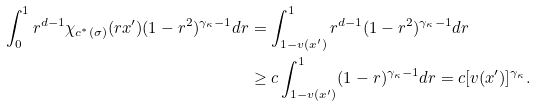Convert formula to latex. <formula><loc_0><loc_0><loc_500><loc_500>\int _ { 0 } ^ { 1 } r ^ { d - 1 } \chi _ { c ^ { * } ( \sigma ) } ( r x ^ { \prime } ) ( 1 - r ^ { 2 } ) ^ { \gamma _ { \kappa } - 1 } d r & = \int _ { 1 - v ( x ^ { \prime } ) } ^ { 1 } r ^ { d - 1 } ( 1 - r ^ { 2 } ) ^ { \gamma _ { \kappa } - 1 } d r \\ & \geq c \int _ { 1 - v ( x ^ { \prime } ) } ^ { 1 } ( 1 - r ) ^ { \gamma _ { \kappa } - 1 } d r = c [ v ( x ^ { \prime } ) ] ^ { \gamma _ { \kappa } } .</formula> 